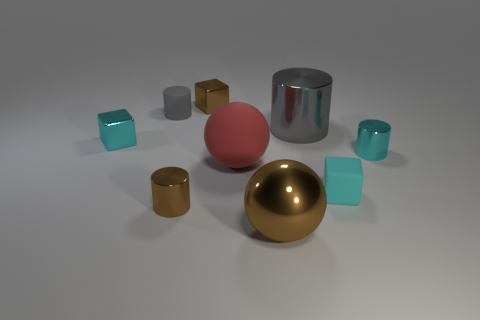Subtract all cyan metal cylinders. How many cylinders are left? 3 Subtract all gray cylinders. How many were subtracted if there are1gray cylinders left? 1 Subtract 1 cubes. How many cubes are left? 2 Subtract all cyan balls. Subtract all gray blocks. How many balls are left? 2 Subtract all purple cubes. How many red balls are left? 1 Subtract all tiny brown things. Subtract all large gray metallic cylinders. How many objects are left? 6 Add 3 cyan objects. How many cyan objects are left? 6 Add 5 blue metal spheres. How many blue metal spheres exist? 5 Add 1 tiny cyan rubber objects. How many objects exist? 10 Subtract all brown blocks. How many blocks are left? 2 